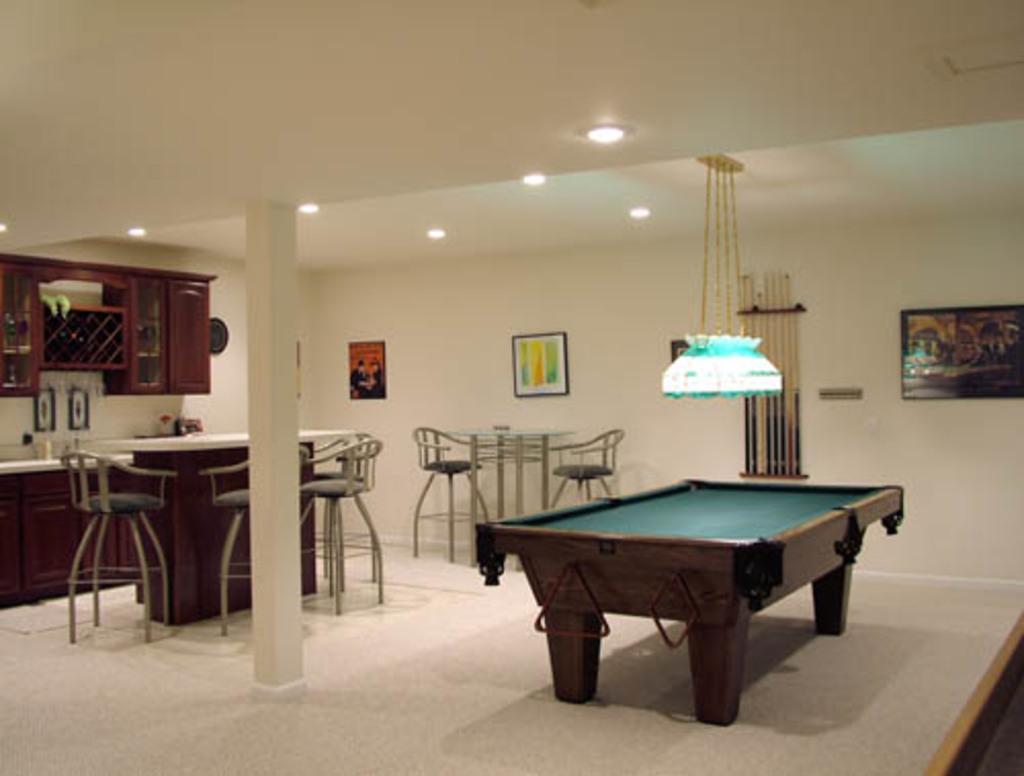Please provide a concise description of this image. In this image I can see number of chairs, a table and a snooker table. I can also see few frames on this wall. 